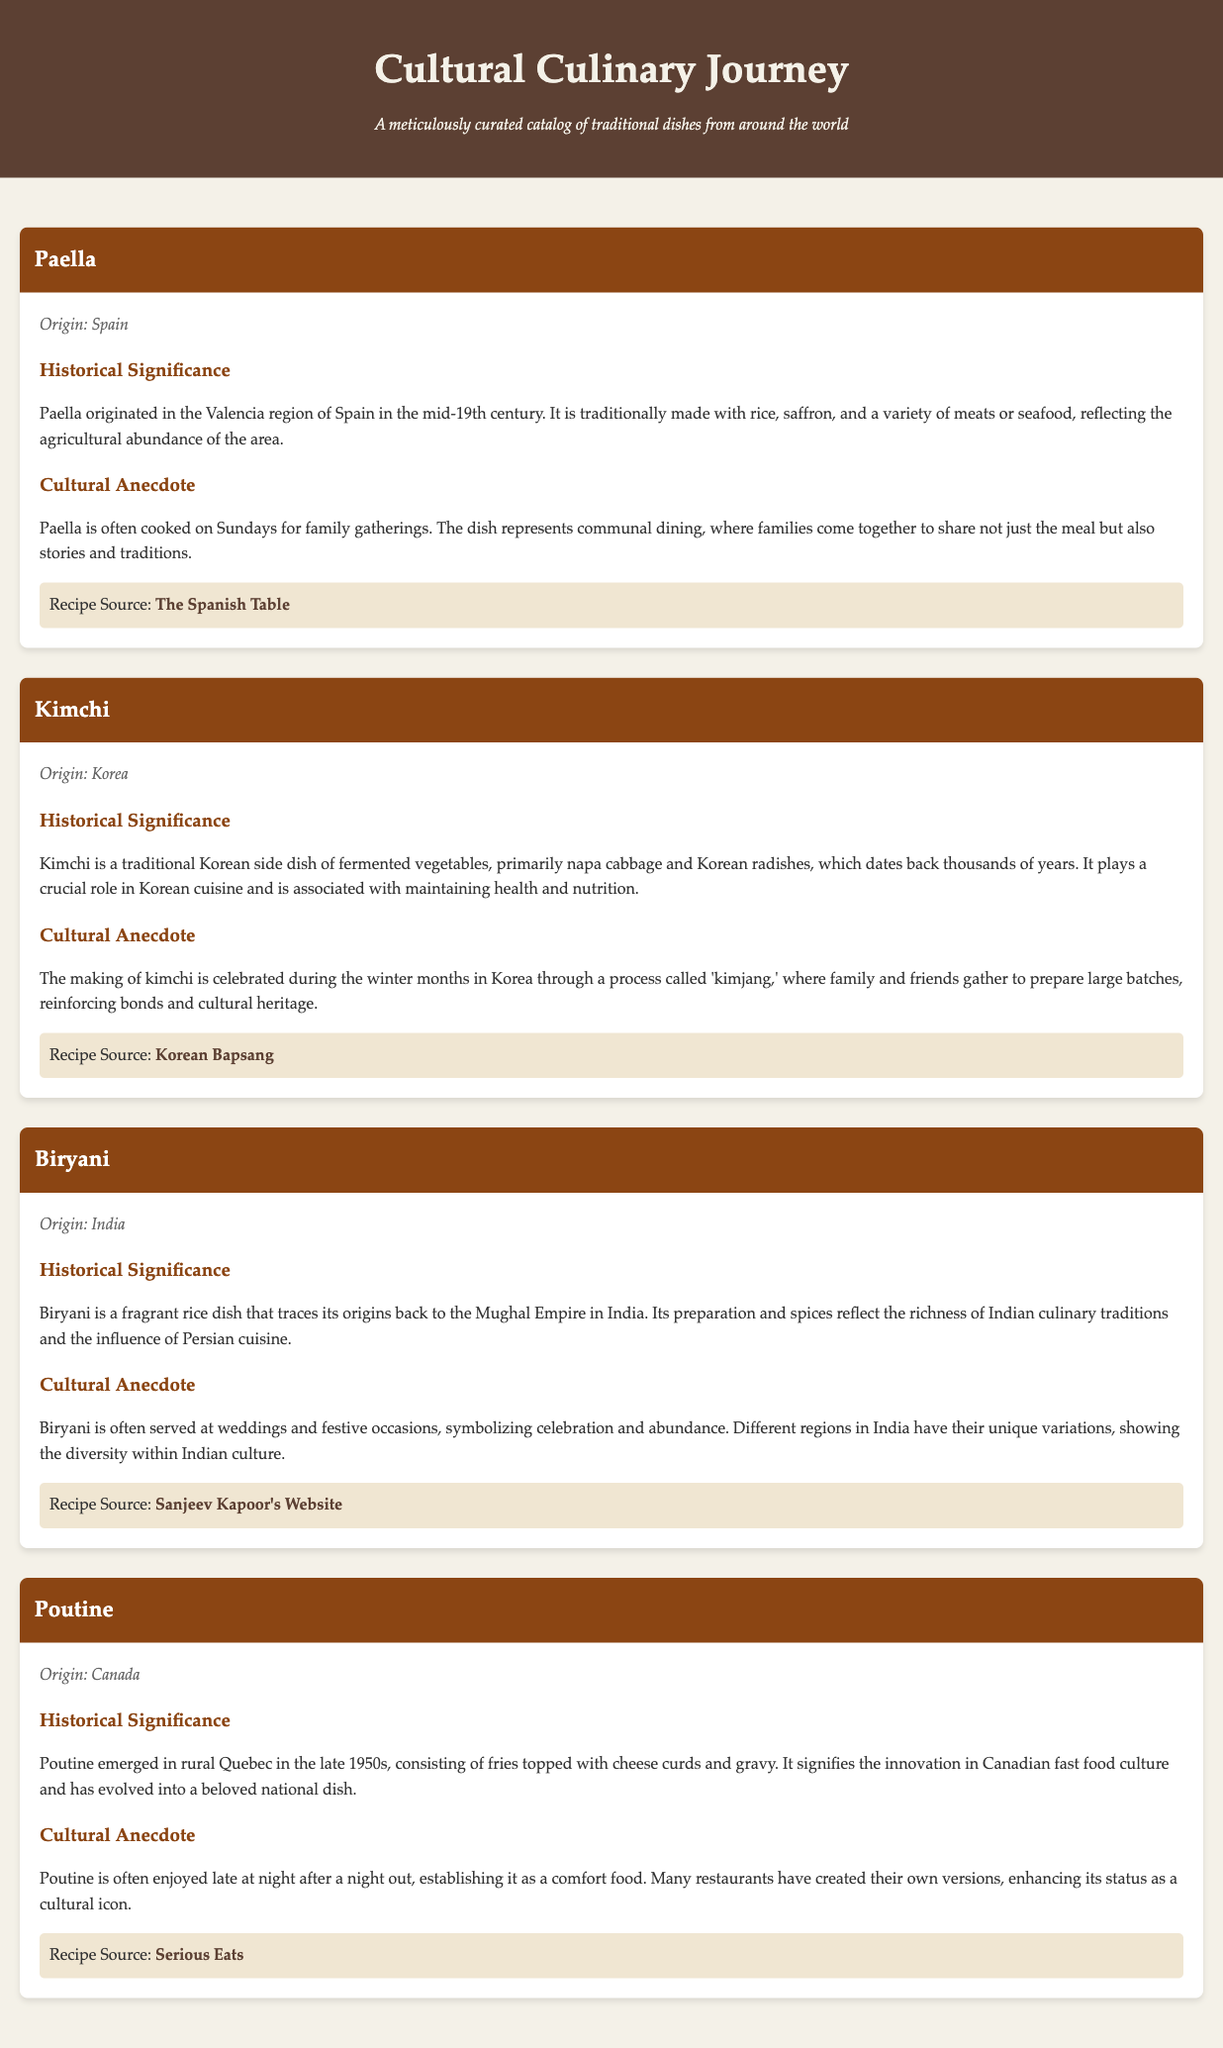What is the origin of Paella? The origin of Paella is noted in the document as being from Spain.
Answer: Spain What key ingredient is used in Kimchi? Kimchi primarily consists of fermented vegetables, with napa cabbage being a key ingredient.
Answer: Napa cabbage When did Poutine emerge in Quebec? The document specifies that Poutine emerged in the late 1950s.
Answer: Late 1950s Which dish is often served at weddings in India? Biryani is particularly mentioned as being served at weddings.
Answer: Biryani What is the recipe source for Paella? The document provides the recipe source for Paella as The Spanish Table.
Answer: The Spanish Table What is the cultural significance of kimjang in Korea? Kimjang is celebrated for gathering family and friends to prepare kimchi, reinforcing bonds and cultural heritage.
Answer: Reinforcing bonds and cultural heritage Which dish represents communal dining in Spain? The document connects Paella with the concept of communal dining.
Answer: Paella What type of card format is used for each dish? Each dish is presented in a dish card format that contains specific details about the dish.
Answer: Dish card What is the main characteristic of Biryani according to its historical significance? The document states that Biryani reflects the richness of Indian culinary traditions and Persian influence.
Answer: Richness of Indian culinary traditions 